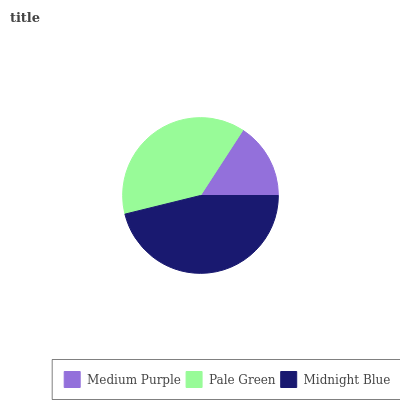Is Medium Purple the minimum?
Answer yes or no. Yes. Is Midnight Blue the maximum?
Answer yes or no. Yes. Is Pale Green the minimum?
Answer yes or no. No. Is Pale Green the maximum?
Answer yes or no. No. Is Pale Green greater than Medium Purple?
Answer yes or no. Yes. Is Medium Purple less than Pale Green?
Answer yes or no. Yes. Is Medium Purple greater than Pale Green?
Answer yes or no. No. Is Pale Green less than Medium Purple?
Answer yes or no. No. Is Pale Green the high median?
Answer yes or no. Yes. Is Pale Green the low median?
Answer yes or no. Yes. Is Medium Purple the high median?
Answer yes or no. No. Is Midnight Blue the low median?
Answer yes or no. No. 